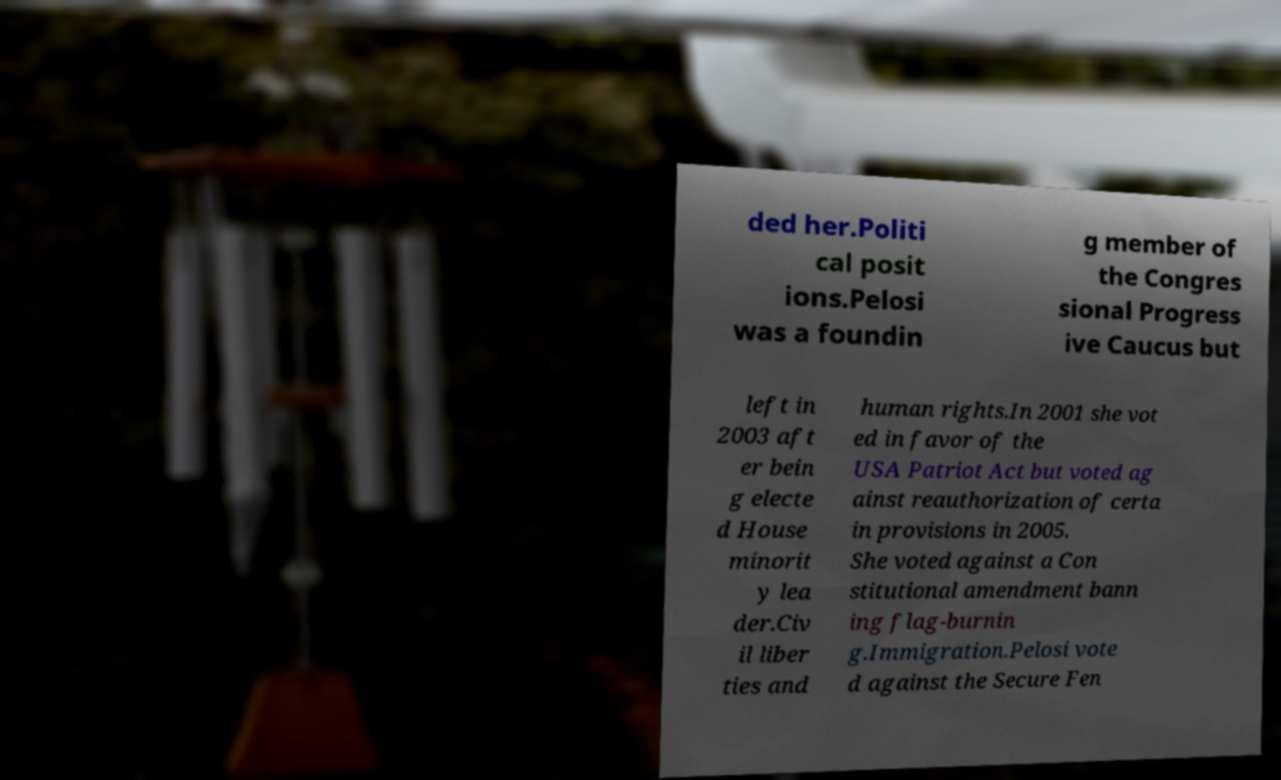Could you assist in decoding the text presented in this image and type it out clearly? ded her.Politi cal posit ions.Pelosi was a foundin g member of the Congres sional Progress ive Caucus but left in 2003 aft er bein g electe d House minorit y lea der.Civ il liber ties and human rights.In 2001 she vot ed in favor of the USA Patriot Act but voted ag ainst reauthorization of certa in provisions in 2005. She voted against a Con stitutional amendment bann ing flag-burnin g.Immigration.Pelosi vote d against the Secure Fen 